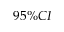Convert formula to latex. <formula><loc_0><loc_0><loc_500><loc_500>9 5 \% C I</formula> 